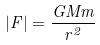<formula> <loc_0><loc_0><loc_500><loc_500>| F | = \frac { G M m } { r ^ { 2 } }</formula> 